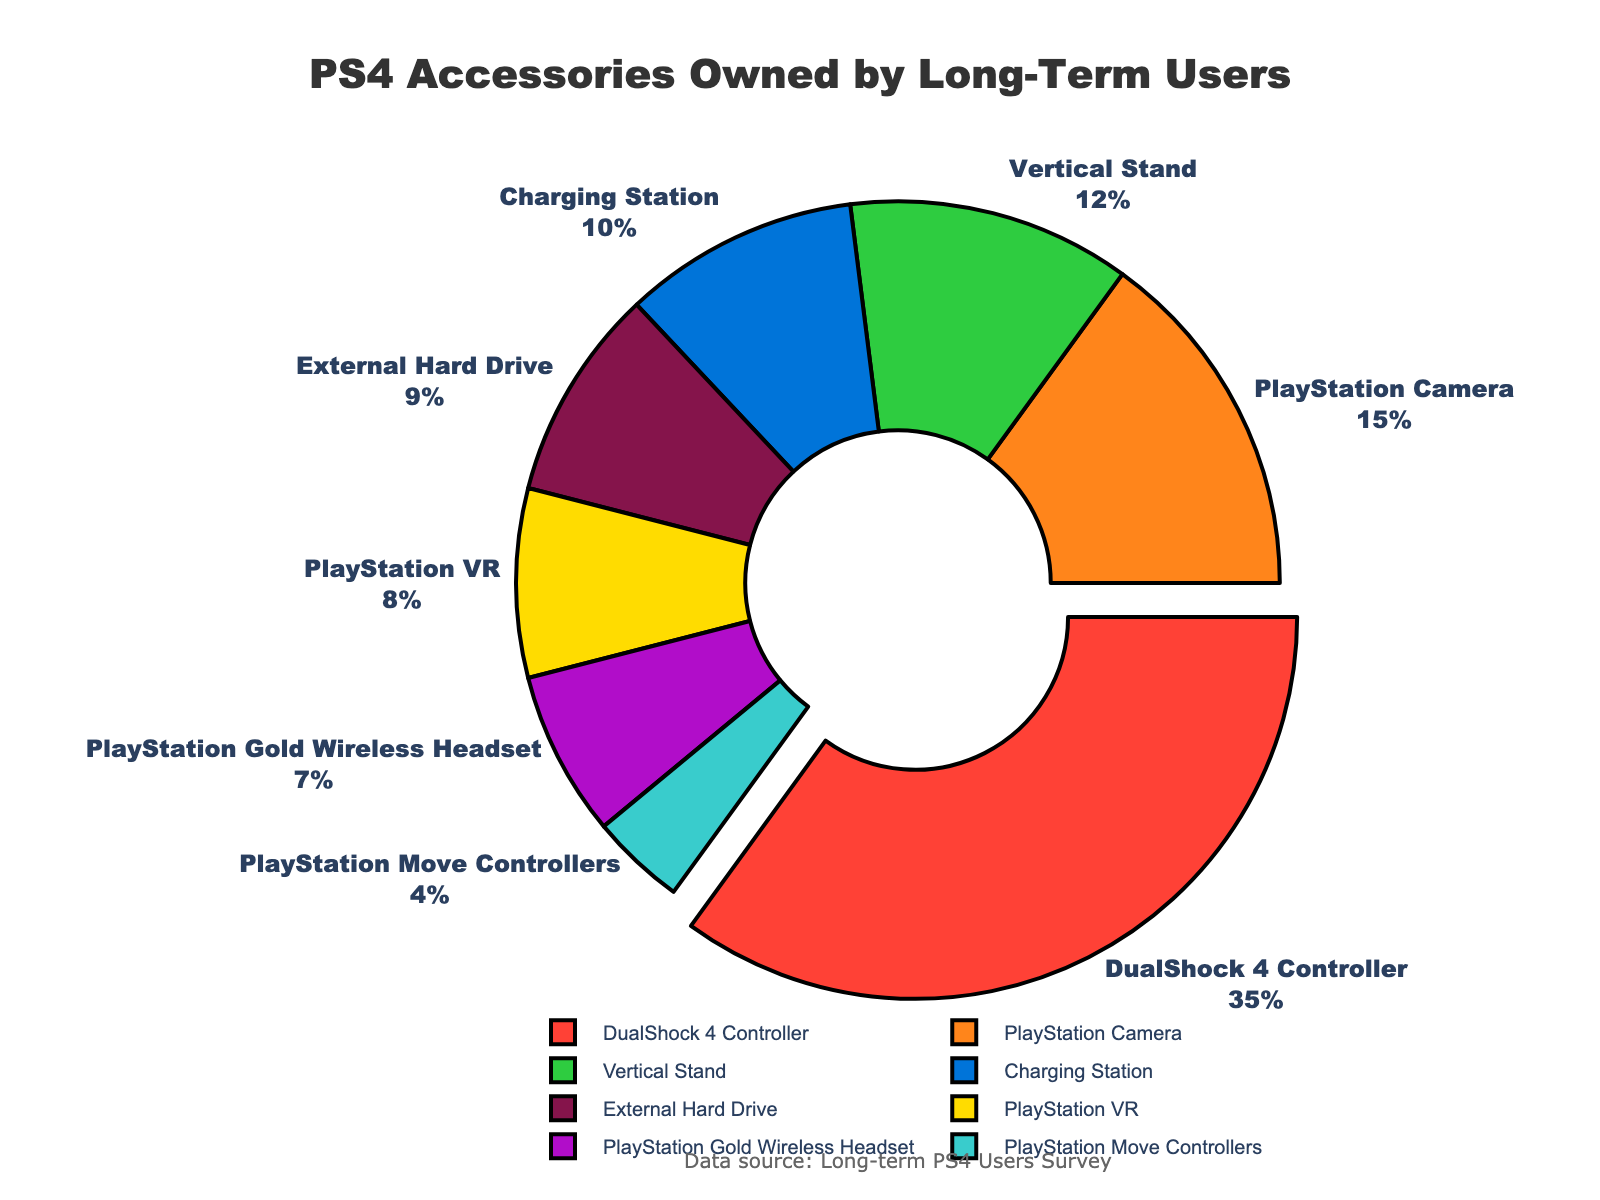What's the most owned PS4 accessory among long-term users? The most owned accessory would have the highest percentage in the pie chart. In this case, the DualShock 4 Controller has the highest percentage at 35%.
Answer: DualShock 4 Controller Which accessory is owned less than the PlayStation VR but more than the PlayStation Move Controllers? Compare the percentages: PlayStation VR is at 8%, and PlayStation Move Controllers are at 4%. The ones in between are the PlayStation Gold Wireless Headset at 7% and the External Hard Drive at 9%. Since 7% is less than 8%, the correct answer is the PlayStation Gold Wireless Headset.
Answer: PlayStation Gold Wireless Headset If we combine the percentages of the PlayStation Camera and External Hard Drive, does it exceed the percentage of the DualShock 4 Controller? Add the percentages of PlayStation Camera (15%) and External Hard Drive (9%): 15 + 9 = 24%. Comparing with the DualShock 4 Controller at 35%, 24% is less than 35%.
Answer: No What is the percentage difference between the Vertical Stand and Charging Station? Subtract the smaller percentage from the larger one: Vertical Stand (12%) - Charging Station (10%) = 2%.
Answer: 2% Which accessory has the smallest representation, and what is its percentage? Identify the accessory with the smallest percentage in the pie chart. The PlayStation Move Controllers have the smallest share at 4%.
Answer: PlayStation Move Controllers, 4% How do the combined percentages of the Vertical Stand and Charging Station compare to the DualShock 4 Controller? Add the percentages of the Vertical Stand (12%) and Charging Station (10%): 12 + 10 = 22%. Compare this to the DualShock 4 Controller at 35%. Since 22% is less than 35%, they do not exceed.
Answer: Less than What color is used to represent the PlayStation VR in the pie chart? Visually identify the color segment labeled as PlayStation VR. According to the color sequence in the code, the PlayStation VR is represented by a shade of green.
Answer: Green Is the percentage of users who own the Charging Station more than the percentage who own the PlayStation VR? Compare the percentages: Charging Station is at 10%, and PlayStation VR is at 8%. Since 10% is greater than 8%, the answer is yes.
Answer: Yes Rank the following accessories by percentage from highest to lowest: Vertical Stand, PlayStation Camera, and PlayStation Gold Wireless Headset. List the percentages: PlayStation Camera (15%), Vertical Stand (12%), and PlayStation Gold Wireless Headset (7%). Now rank them from highest to lowest: PlayStation Camera, Vertical Stand, PlayStation Gold Wireless Headset.
Answer: PlayStation Camera, Vertical Stand, PlayStation Gold Wireless Headset 